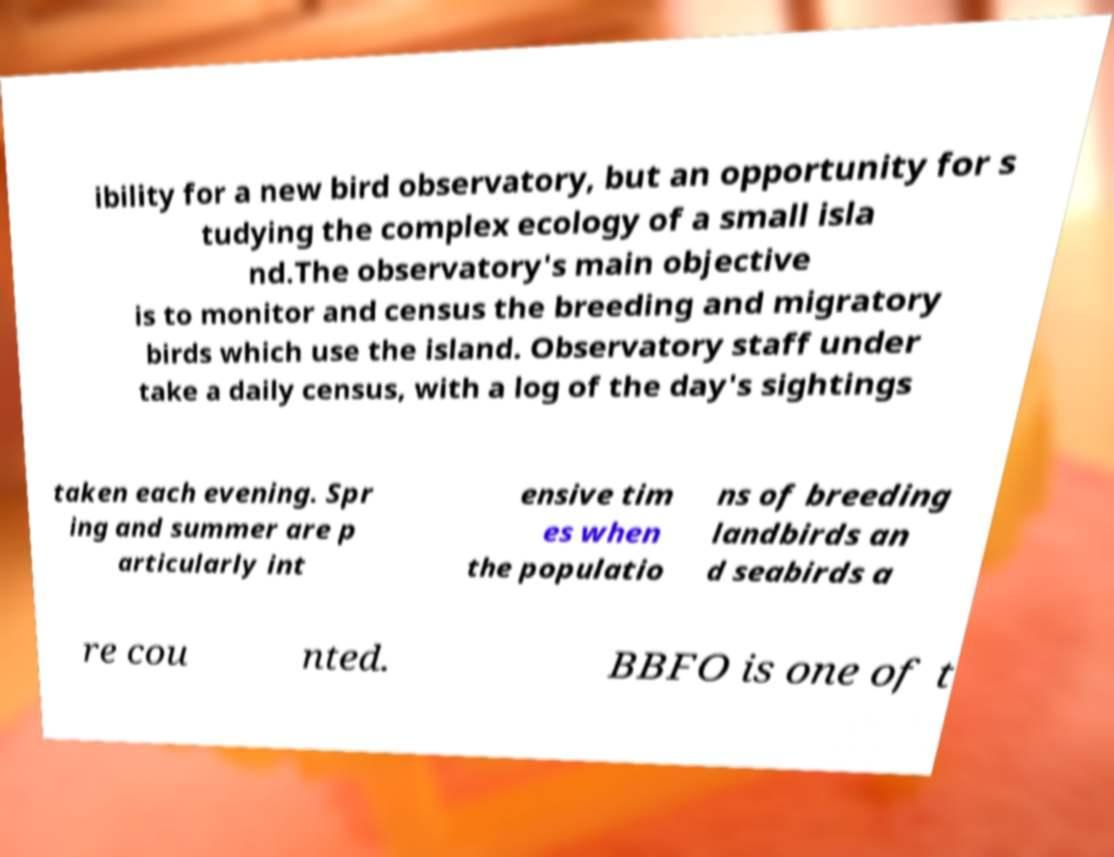I need the written content from this picture converted into text. Can you do that? ibility for a new bird observatory, but an opportunity for s tudying the complex ecology of a small isla nd.The observatory's main objective is to monitor and census the breeding and migratory birds which use the island. Observatory staff under take a daily census, with a log of the day's sightings taken each evening. Spr ing and summer are p articularly int ensive tim es when the populatio ns of breeding landbirds an d seabirds a re cou nted. BBFO is one of t 